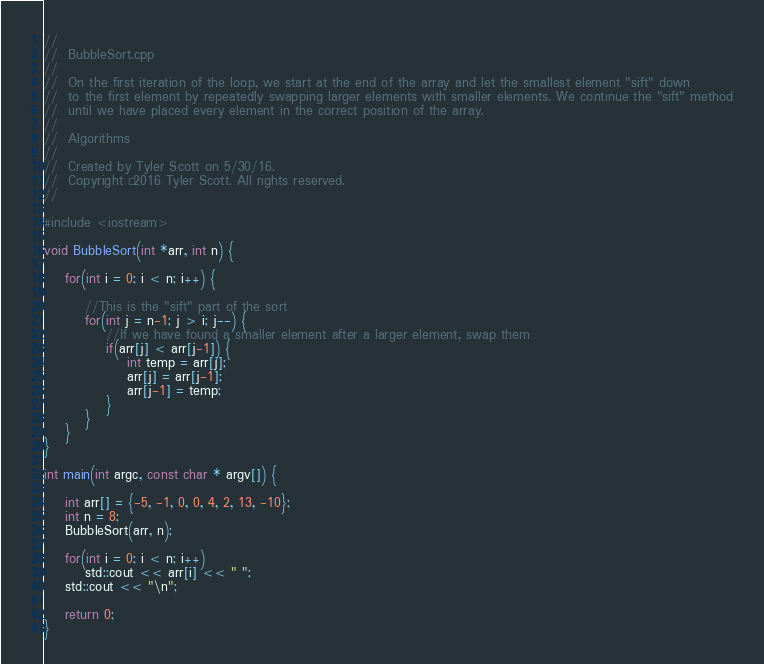Convert code to text. <code><loc_0><loc_0><loc_500><loc_500><_C++_>//
//  BubbleSort.cpp
//
//  On the first iteration of the loop, we start at the end of the array and let the smallest element "sift" down
//  to the first element by repeatedly swapping larger elements with smaller elements. We continue the "sift" method
//  until we have placed every element in the correct position of the array.
//
//  Algorithms
//
//  Created by Tyler Scott on 5/30/16.
//  Copyright © 2016 Tyler Scott. All rights reserved.
//

#include <iostream>

void BubbleSort(int *arr, int n) {
    
    for(int i = 0; i < n; i++) {
        
        //This is the "sift" part of the sort
        for(int j = n-1; j > i; j--) {
            //If we have found a smaller element after a larger element, swap them
            if(arr[j] < arr[j-1]) {
                int temp = arr[j];
                arr[j] = arr[j-1];
                arr[j-1] = temp;
            }
        }
    }
}

int main(int argc, const char * argv[]) {
    
    int arr[] = {-5, -1, 0, 0, 4, 2, 13, -10};
    int n = 8;
    BubbleSort(arr, n);
    
    for(int i = 0; i < n; i++)
        std::cout << arr[i] << " ";
    std::cout << "\n";
    
    return 0;
}
</code> 